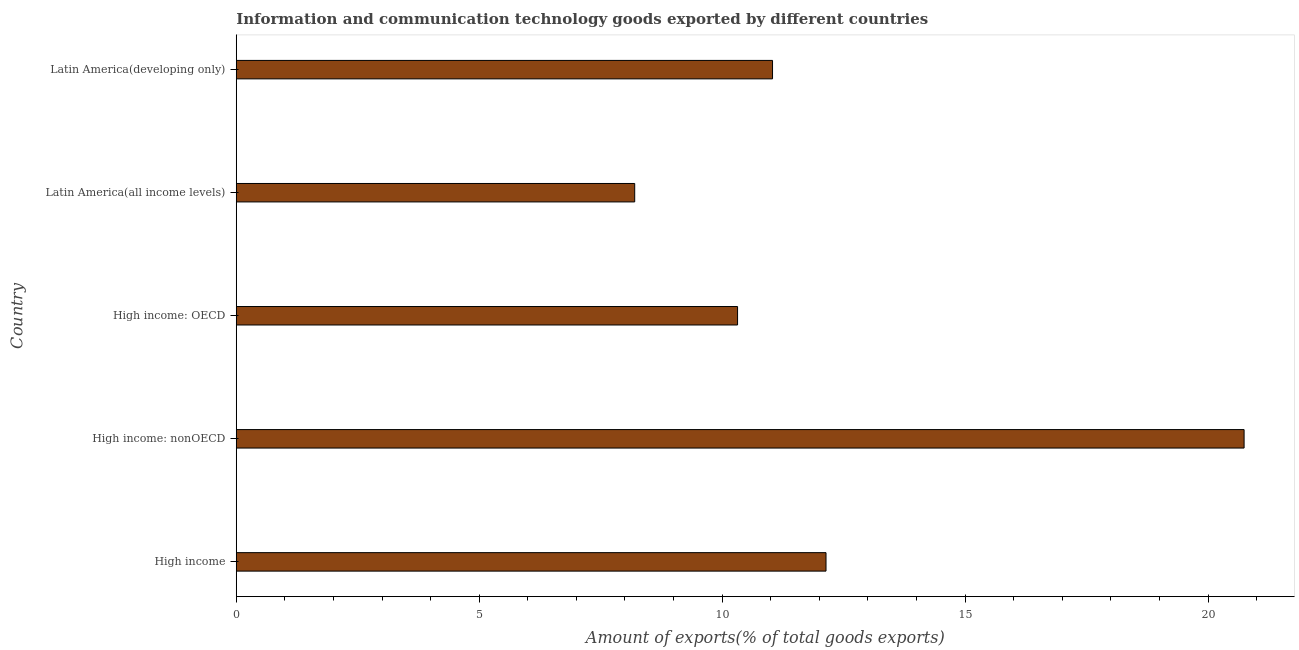Does the graph contain grids?
Your response must be concise. No. What is the title of the graph?
Make the answer very short. Information and communication technology goods exported by different countries. What is the label or title of the X-axis?
Give a very brief answer. Amount of exports(% of total goods exports). What is the label or title of the Y-axis?
Ensure brevity in your answer.  Country. What is the amount of ict goods exports in High income: nonOECD?
Your answer should be very brief. 20.74. Across all countries, what is the maximum amount of ict goods exports?
Provide a succinct answer. 20.74. Across all countries, what is the minimum amount of ict goods exports?
Offer a terse response. 8.2. In which country was the amount of ict goods exports maximum?
Make the answer very short. High income: nonOECD. In which country was the amount of ict goods exports minimum?
Ensure brevity in your answer.  Latin America(all income levels). What is the sum of the amount of ict goods exports?
Offer a terse response. 62.44. What is the difference between the amount of ict goods exports in High income and High income: OECD?
Your answer should be compact. 1.82. What is the average amount of ict goods exports per country?
Your answer should be compact. 12.49. What is the median amount of ict goods exports?
Give a very brief answer. 11.04. In how many countries, is the amount of ict goods exports greater than 16 %?
Your answer should be compact. 1. What is the ratio of the amount of ict goods exports in High income: OECD to that in High income: nonOECD?
Keep it short and to the point. 0.5. Is the amount of ict goods exports in High income: OECD less than that in Latin America(developing only)?
Your answer should be compact. Yes. Is the difference between the amount of ict goods exports in High income: nonOECD and Latin America(all income levels) greater than the difference between any two countries?
Keep it short and to the point. Yes. What is the difference between the highest and the second highest amount of ict goods exports?
Make the answer very short. 8.61. What is the difference between the highest and the lowest amount of ict goods exports?
Your response must be concise. 12.54. In how many countries, is the amount of ict goods exports greater than the average amount of ict goods exports taken over all countries?
Offer a terse response. 1. How many bars are there?
Offer a terse response. 5. Are all the bars in the graph horizontal?
Provide a succinct answer. Yes. What is the Amount of exports(% of total goods exports) of High income?
Provide a short and direct response. 12.14. What is the Amount of exports(% of total goods exports) in High income: nonOECD?
Your answer should be very brief. 20.74. What is the Amount of exports(% of total goods exports) of High income: OECD?
Provide a short and direct response. 10.32. What is the Amount of exports(% of total goods exports) in Latin America(all income levels)?
Your response must be concise. 8.2. What is the Amount of exports(% of total goods exports) in Latin America(developing only)?
Your answer should be compact. 11.04. What is the difference between the Amount of exports(% of total goods exports) in High income and High income: nonOECD?
Give a very brief answer. -8.6. What is the difference between the Amount of exports(% of total goods exports) in High income and High income: OECD?
Ensure brevity in your answer.  1.82. What is the difference between the Amount of exports(% of total goods exports) in High income and Latin America(all income levels)?
Your response must be concise. 3.94. What is the difference between the Amount of exports(% of total goods exports) in High income and Latin America(developing only)?
Your answer should be compact. 1.1. What is the difference between the Amount of exports(% of total goods exports) in High income: nonOECD and High income: OECD?
Your response must be concise. 10.43. What is the difference between the Amount of exports(% of total goods exports) in High income: nonOECD and Latin America(all income levels)?
Make the answer very short. 12.54. What is the difference between the Amount of exports(% of total goods exports) in High income: nonOECD and Latin America(developing only)?
Your answer should be compact. 9.71. What is the difference between the Amount of exports(% of total goods exports) in High income: OECD and Latin America(all income levels)?
Ensure brevity in your answer.  2.12. What is the difference between the Amount of exports(% of total goods exports) in High income: OECD and Latin America(developing only)?
Offer a terse response. -0.72. What is the difference between the Amount of exports(% of total goods exports) in Latin America(all income levels) and Latin America(developing only)?
Give a very brief answer. -2.84. What is the ratio of the Amount of exports(% of total goods exports) in High income to that in High income: nonOECD?
Provide a succinct answer. 0.58. What is the ratio of the Amount of exports(% of total goods exports) in High income to that in High income: OECD?
Provide a short and direct response. 1.18. What is the ratio of the Amount of exports(% of total goods exports) in High income to that in Latin America(all income levels)?
Offer a very short reply. 1.48. What is the ratio of the Amount of exports(% of total goods exports) in High income to that in Latin America(developing only)?
Ensure brevity in your answer.  1.1. What is the ratio of the Amount of exports(% of total goods exports) in High income: nonOECD to that in High income: OECD?
Your response must be concise. 2.01. What is the ratio of the Amount of exports(% of total goods exports) in High income: nonOECD to that in Latin America(all income levels)?
Give a very brief answer. 2.53. What is the ratio of the Amount of exports(% of total goods exports) in High income: nonOECD to that in Latin America(developing only)?
Offer a very short reply. 1.88. What is the ratio of the Amount of exports(% of total goods exports) in High income: OECD to that in Latin America(all income levels)?
Your answer should be compact. 1.26. What is the ratio of the Amount of exports(% of total goods exports) in High income: OECD to that in Latin America(developing only)?
Your response must be concise. 0.94. What is the ratio of the Amount of exports(% of total goods exports) in Latin America(all income levels) to that in Latin America(developing only)?
Keep it short and to the point. 0.74. 